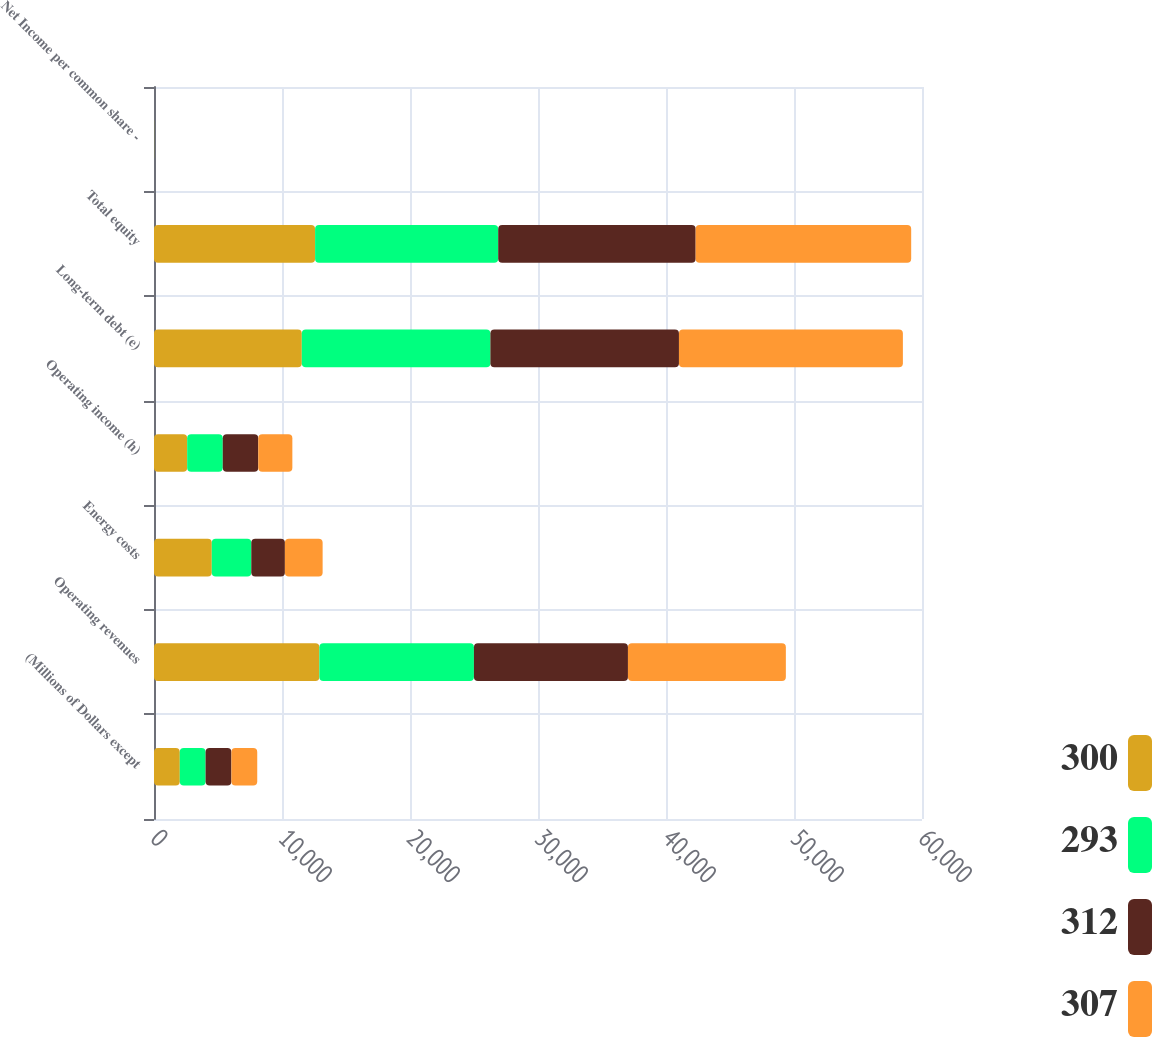<chart> <loc_0><loc_0><loc_500><loc_500><stacked_bar_chart><ecel><fcel>(Millions of Dollars except<fcel>Operating revenues<fcel>Energy costs<fcel>Operating income (h)<fcel>Long-term debt (e)<fcel>Total equity<fcel>Net Income per common share -<nl><fcel>300<fcel>2014<fcel>12919<fcel>4513<fcel>2591<fcel>11546<fcel>12585<fcel>3.71<nl><fcel>293<fcel>2016<fcel>12075<fcel>3088<fcel>2780<fcel>14735<fcel>14306<fcel>4.12<nl><fcel>312<fcel>2017<fcel>12033<fcel>2625<fcel>2774<fcel>14731<fcel>15425<fcel>4.94<nl><fcel>307<fcel>2018<fcel>12337<fcel>2948<fcel>2664<fcel>17495<fcel>16839<fcel>4.42<nl></chart> 